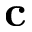Convert formula to latex. <formula><loc_0><loc_0><loc_500><loc_500>c</formula> 